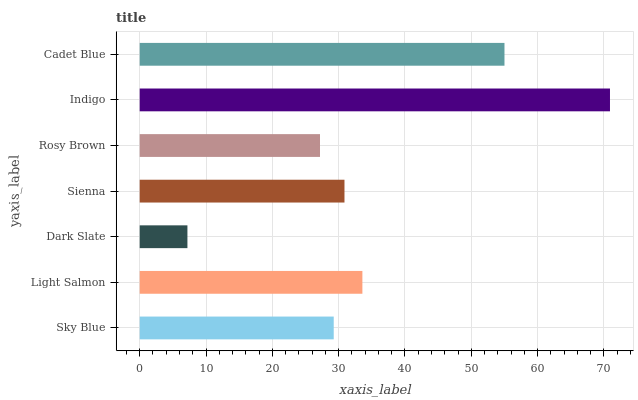Is Dark Slate the minimum?
Answer yes or no. Yes. Is Indigo the maximum?
Answer yes or no. Yes. Is Light Salmon the minimum?
Answer yes or no. No. Is Light Salmon the maximum?
Answer yes or no. No. Is Light Salmon greater than Sky Blue?
Answer yes or no. Yes. Is Sky Blue less than Light Salmon?
Answer yes or no. Yes. Is Sky Blue greater than Light Salmon?
Answer yes or no. No. Is Light Salmon less than Sky Blue?
Answer yes or no. No. Is Sienna the high median?
Answer yes or no. Yes. Is Sienna the low median?
Answer yes or no. Yes. Is Rosy Brown the high median?
Answer yes or no. No. Is Cadet Blue the low median?
Answer yes or no. No. 